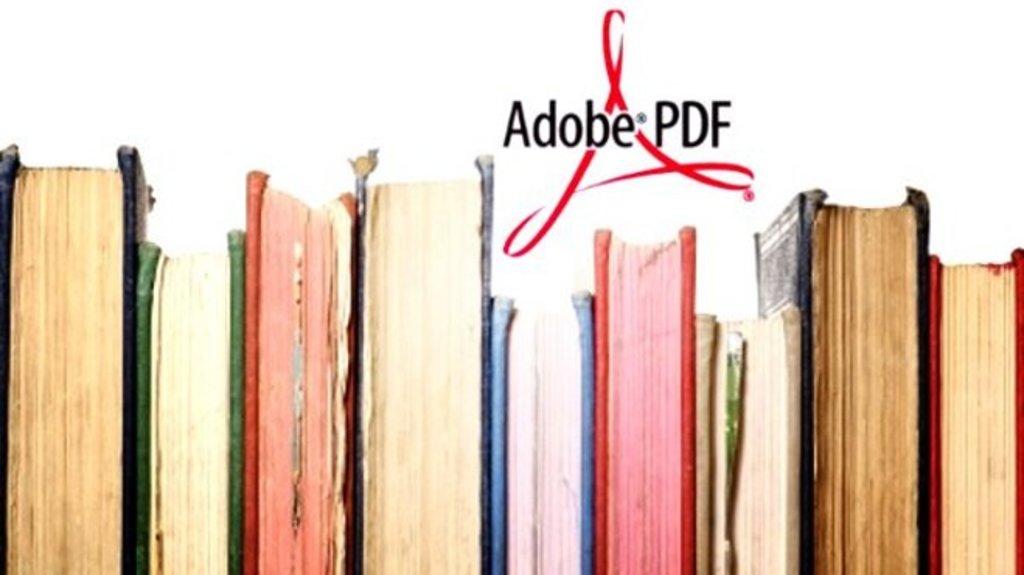What kind of program was used to make this pdf?
Ensure brevity in your answer.  Adobe. 